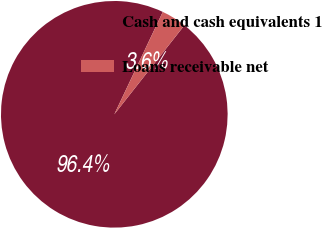<chart> <loc_0><loc_0><loc_500><loc_500><pie_chart><fcel>Cash and cash equivalents 1<fcel>Loans receivable net<nl><fcel>96.42%<fcel>3.58%<nl></chart> 